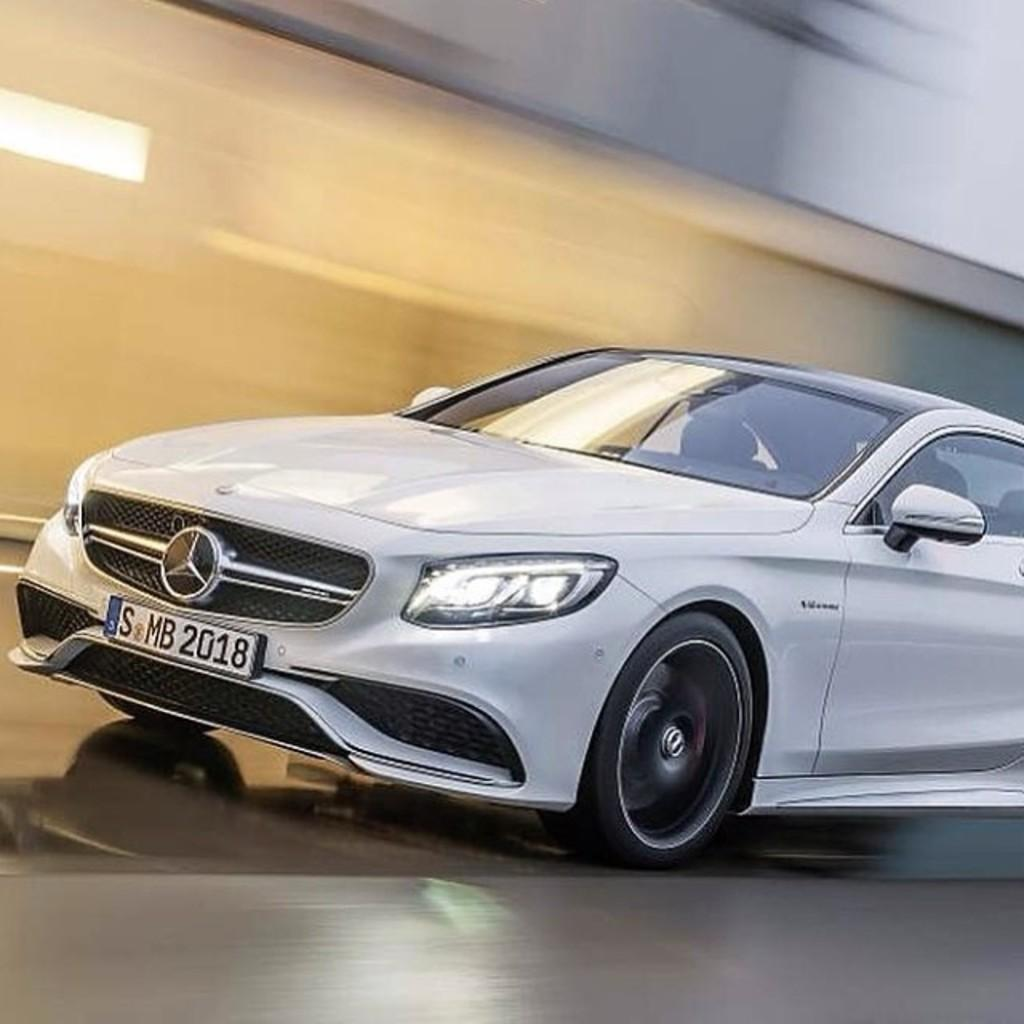What is the main subject of the image? The main subject of the image is a car. Where is the car located in the image? The car is on the road in the image. What else can be seen in the image besides the car? There is a wall in the image. How many branches are hanging from the car in the image? There are no branches hanging from the car in the image. What type of tray is placed on the roof of the car in the image? There is no tray present on the roof of the car in the image. 